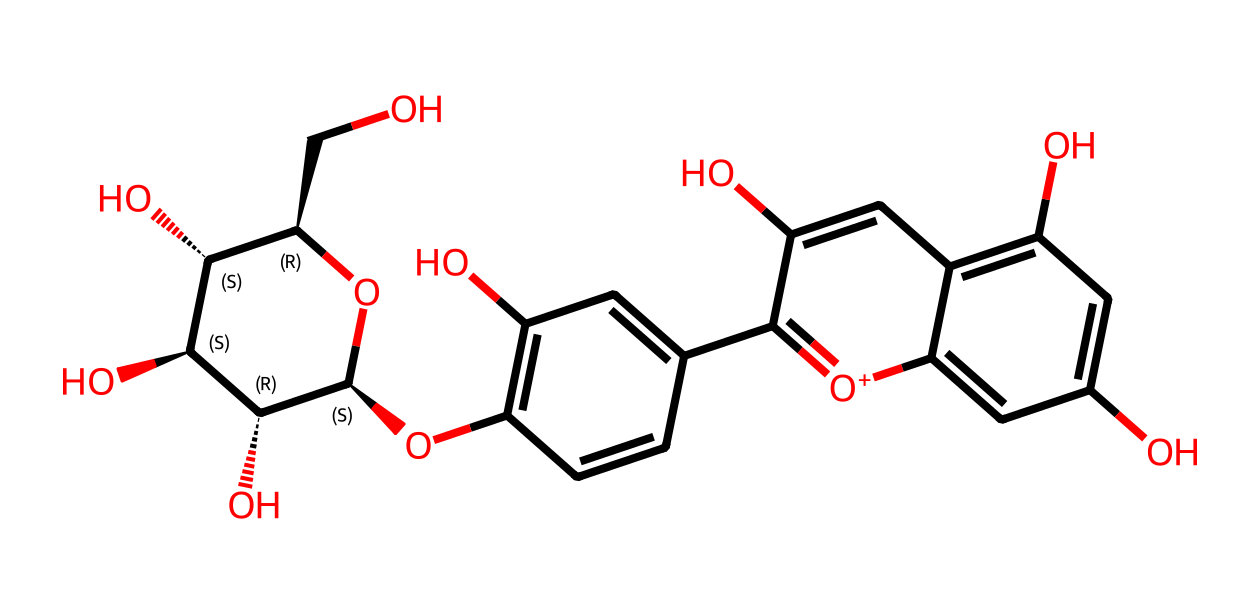What is the main function of anthocyanins in grapes? Anthocyanins function primarily as pigments, providing the red, blue, and purple colors in grapes, which can attract pollinators and contribute to the fruit's maturity signaling.
Answer: pigments How many hydroxyl (-OH) groups are present in this structure? By examining the structure, we can count the number of hydroxyl groups, which are attached to certain carbon atoms. In total, there are five -OH groups in the structure.
Answer: five What type of bonding is primarily present in anthocyanins? The structure indicates multiple carbon-carbon (C-C) bonds and carbon-oxygen (C-O) bonds, typical of organic compounds. The predominant bond type is covalent bonding.
Answer: covalent What is the oxidation state of the central carbon in the five-membered ring of the anthocyanin structure? The central carbon is bonded to two oxygens and two other carbons. Its formal charge and bonding suggest it is in a positive oxidation state due to the presence of the positively charged oxygen.
Answer: positive Identify the stereocenters in this molecule. In the SMILES representation, the stereocenters are denoted by the '@' symbols, indicating that there are multiple chiral centers associated with the attached groups. The molecule has four stereocenters.
Answer: four How do anthocyanins contribute to the health benefits of grapes? Anthocyanins are known for their antioxidant properties, which help in combating oxidative stress and may reduce inflammation and disease risk.
Answer: antioxidant What is the overall charge of this molecule? Observing the structure, there is a presence of a positively charged oxygen atom while the rest of the molecule maintains neutrality, leading to an overall positive charge.
Answer: positive 